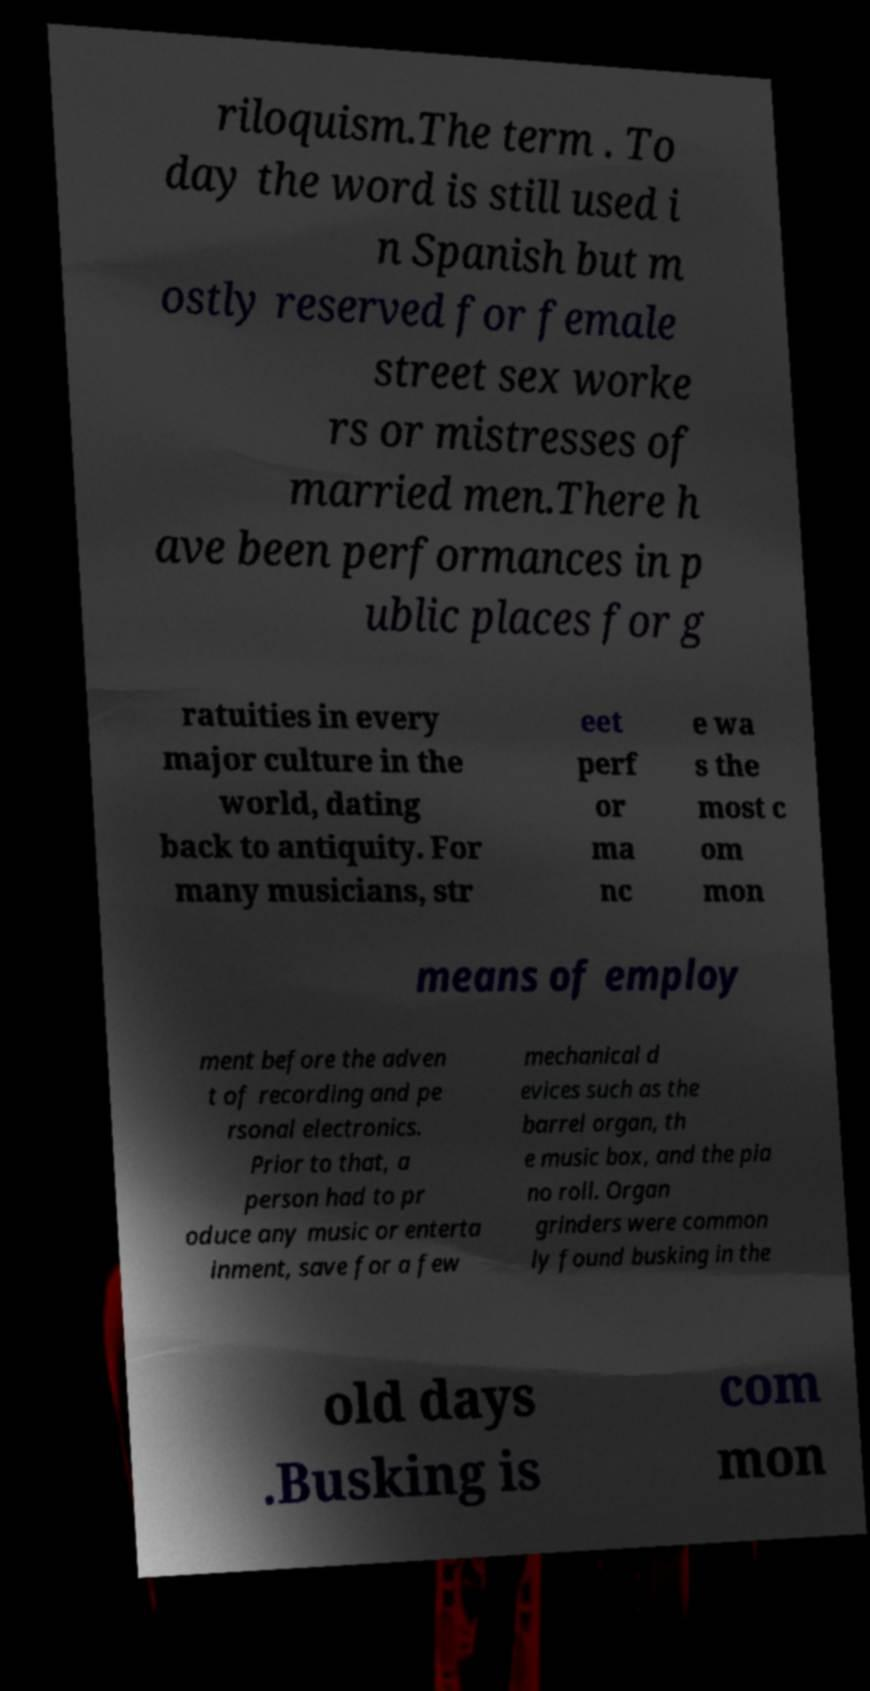Can you accurately transcribe the text from the provided image for me? riloquism.The term . To day the word is still used i n Spanish but m ostly reserved for female street sex worke rs or mistresses of married men.There h ave been performances in p ublic places for g ratuities in every major culture in the world, dating back to antiquity. For many musicians, str eet perf or ma nc e wa s the most c om mon means of employ ment before the adven t of recording and pe rsonal electronics. Prior to that, a person had to pr oduce any music or enterta inment, save for a few mechanical d evices such as the barrel organ, th e music box, and the pia no roll. Organ grinders were common ly found busking in the old days .Busking is com mon 